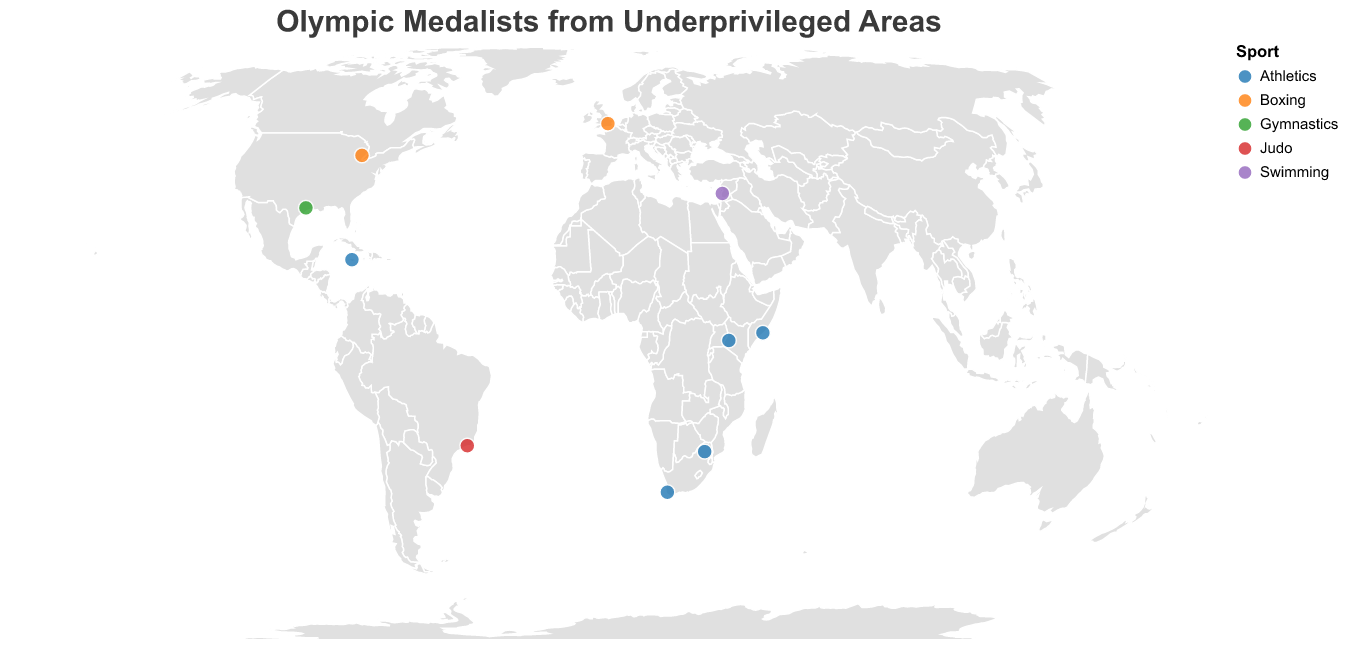How many athletes are mapped on this figure? The figure plots circles representing individual athletes. Each athlete is a data point marked by a circle on the world map. Count all circles to determine the total number of athletes.
Answer: 10 Which athlete's hometown is the southernmost point on the map? The southernmost point corresponds to the data point with the lowest latitude value. Identify the athlete with the lowest latitude coordinate among the data points.
Answer: Wayde van Niekerk Which country has the most athletes represented? Count the data points for each country based on the tooltip information showing the country name. The country with the highest count has the most athletes represented.
Answer: USA Which sport is represented by the most athletes in this figure? Examine the tooltip information to see the 'Sport' field for each data point. Count the occurrences of each sport and find the one with the highest count.
Answer: Athletics What is the color used to represent Judo in this plot? Identify the color scheme used for sports by matching the colors in the figure to the 'Sport' field in the tooltip. Find the color used for the data point that lists 'Judo' as the sport.
Answer: Light blue What is the combined total of gold medals won by athletes from the USA on this map? Identify all athletes from the USA using the tooltip information. Sum the number of gold medals mentioned for USA athletes in the tooltip data.
Answer: 3 Which athlete is from the highest latitude location? The highest latitude corresponds to the data point with the highest latitude value. Identify the athlete with the highest latitude coordinate among the data points.
Answer: Claressa Shields Compare the latitudinal positions of Anthony Joshua and Mo Farah’s hometowns. Is Joshua's hometown farther north than Farah's? Compare the latitude values of Anthony Joshua's hometown (Watford) and Mo Farah's hometown (Mogadishu). Check if Joshua's latitude is greater than Farah's.
Answer: Yes What are the hometowns of all athletes from Africa displayed on this map? Identify all athletes from African countries (South Africa and Kenya) and the Refugee Olympic Team. List the 'Hometown' values from the tooltip information for these athletes.
Answer: Ga-Masehlong, Kraaifontein, Kapsisiywa, Damascus Is there an athlete in the plot with no specific country representation? If yes, what's their sport? Check all the tooltip data for the 'Country' field to see if any athlete is listed as being from the "Refugee Olympic Team". Note the sport associated with this athlete.
Answer: Yes, Swimming 